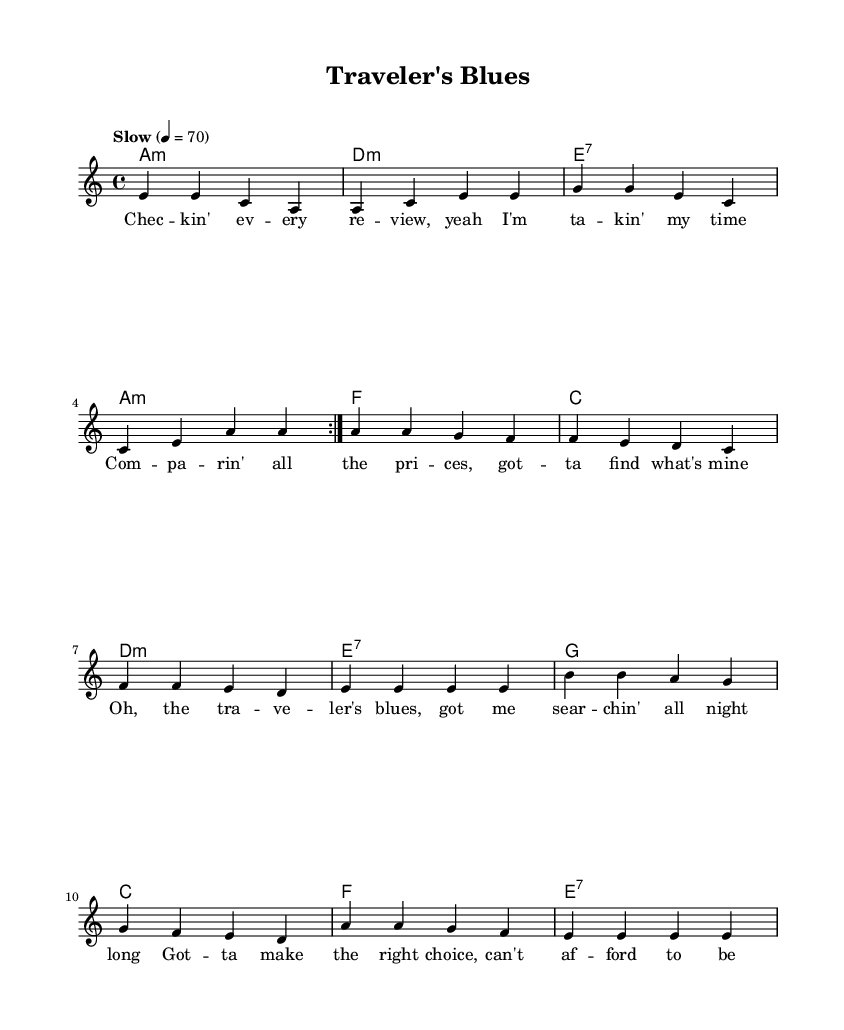What is the key signature of this music? The key signature is A minor, which has no sharps or flats. A minor is the relative minor of C major.
Answer: A minor What is the time signature of this music? The time signature is 4/4, indicating four beats per measure and a quarter note receives one beat.
Answer: 4/4 What is the tempo marking for the music? The tempo marking indicates "Slow" with a metronome marking of 4 = 70, meaning there are 70 beats per minute.
Answer: Slow How many measures are repeated in the first section? The first section is repeated 2 times, indicated by the "repeat volta 2" notation which shows that the music will play that section two times before moving on.
Answer: 2 What type of seventh chord is used in the harmonies? The music includes an E7 chord, which is a dominant seventh chord built on the note E, consisting of the notes E, G#, B, and D.
Answer: E7 How many distinct lyrical phrases are there in the song? The lyrics consist of distinct phrases that can be divided into 6 separate lines, each contributing to the overarching theme of careful decision-making and planning in travel.
Answer: 6 What is a unique characteristic of the blues style shown in this piece? A unique characteristic of this blues piece is the incorporation of a call-and-response structure, particularly evident in the interaction between the lyrical content and the melodic phrases that echo the themes presented in the lyrics.
Answer: Call-and-response 